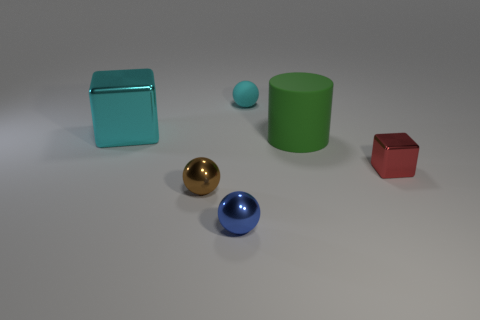Add 1 small blue cylinders. How many objects exist? 7 Subtract all cyan spheres. How many spheres are left? 2 Add 2 cyan shiny objects. How many cyan shiny objects are left? 3 Add 3 purple blocks. How many purple blocks exist? 3 Subtract all red blocks. How many blocks are left? 1 Subtract 0 yellow spheres. How many objects are left? 6 Subtract all cylinders. How many objects are left? 5 Subtract 1 cubes. How many cubes are left? 1 Subtract all yellow spheres. Subtract all purple blocks. How many spheres are left? 3 Subtract all gray balls. How many red cylinders are left? 0 